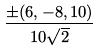Convert formula to latex. <formula><loc_0><loc_0><loc_500><loc_500>\frac { \pm ( 6 , - 8 , 1 0 ) } { 1 0 \sqrt { 2 } }</formula> 